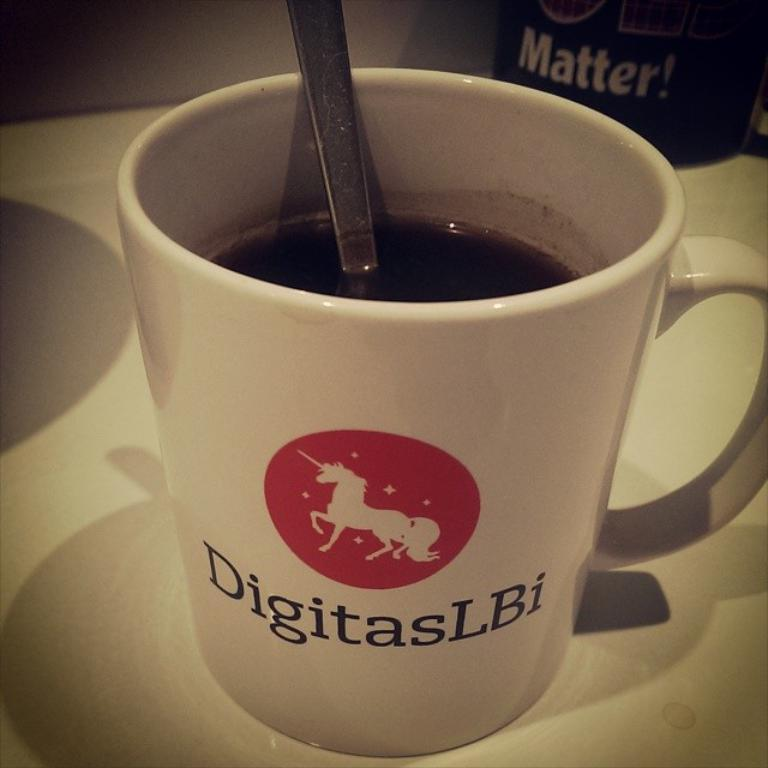<image>
Share a concise interpretation of the image provided. Cup with a straw in it that says DigitasLBi on the front. 